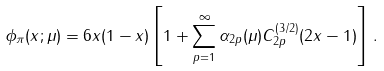<formula> <loc_0><loc_0><loc_500><loc_500>\phi _ { \pi } ( x ; \mu ) = 6 x ( 1 - x ) \left [ 1 + \sum _ { p = 1 } ^ { \infty } \alpha _ { 2 p } ( \mu ) C _ { 2 p } ^ { ( 3 / 2 ) } ( 2 x - 1 ) \right ] \, .</formula> 